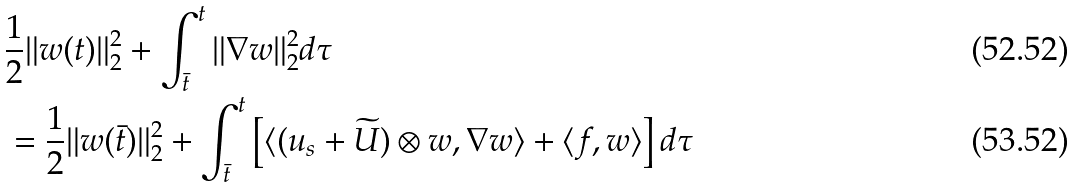<formula> <loc_0><loc_0><loc_500><loc_500>& \frac { 1 } { 2 } \| w ( t ) \| _ { 2 } ^ { 2 } + \int _ { \bar { t } } ^ { t } \| \nabla w \| _ { 2 } ^ { 2 } d \tau \\ & = \frac { 1 } { 2 } \| w ( \bar { t } ) \| _ { 2 } ^ { 2 } + \int _ { \bar { t } } ^ { t } \left [ \langle ( u _ { s } + \widetilde { U } ) \otimes w , \nabla w \rangle + \langle f , w \rangle \right ] d \tau</formula> 